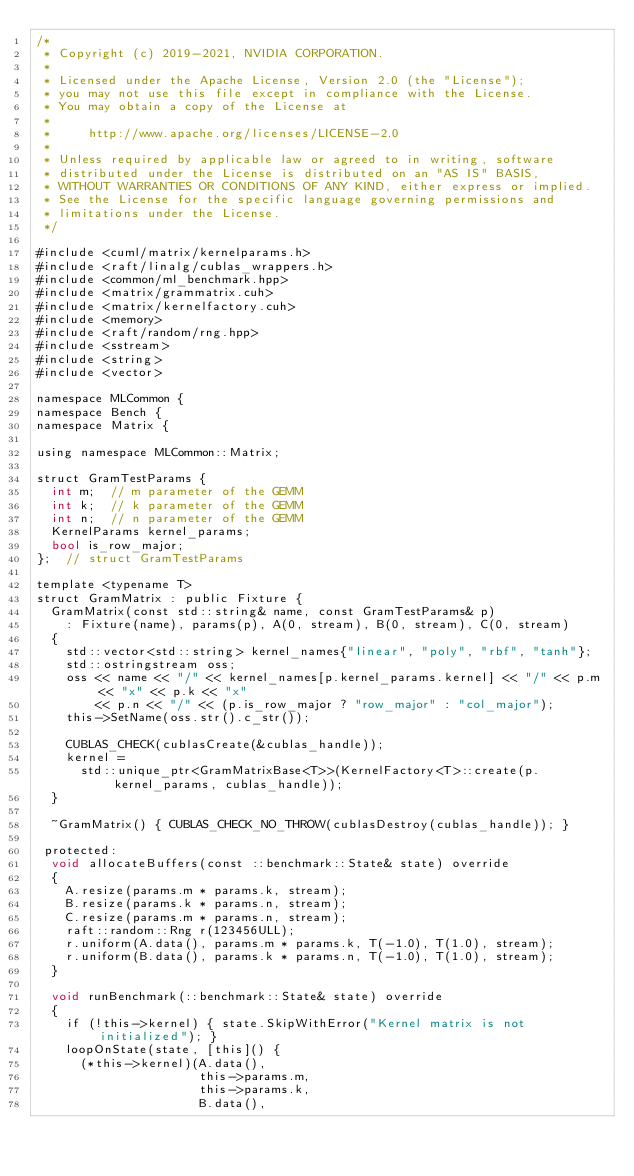Convert code to text. <code><loc_0><loc_0><loc_500><loc_500><_Cuda_>/*
 * Copyright (c) 2019-2021, NVIDIA CORPORATION.
 *
 * Licensed under the Apache License, Version 2.0 (the "License");
 * you may not use this file except in compliance with the License.
 * You may obtain a copy of the License at
 *
 *     http://www.apache.org/licenses/LICENSE-2.0
 *
 * Unless required by applicable law or agreed to in writing, software
 * distributed under the License is distributed on an "AS IS" BASIS,
 * WITHOUT WARRANTIES OR CONDITIONS OF ANY KIND, either express or implied.
 * See the License for the specific language governing permissions and
 * limitations under the License.
 */

#include <cuml/matrix/kernelparams.h>
#include <raft/linalg/cublas_wrappers.h>
#include <common/ml_benchmark.hpp>
#include <matrix/grammatrix.cuh>
#include <matrix/kernelfactory.cuh>
#include <memory>
#include <raft/random/rng.hpp>
#include <sstream>
#include <string>
#include <vector>

namespace MLCommon {
namespace Bench {
namespace Matrix {

using namespace MLCommon::Matrix;

struct GramTestParams {
  int m;  // m parameter of the GEMM
  int k;  // k parameter of the GEMM
  int n;  // n parameter of the GEMM
  KernelParams kernel_params;
  bool is_row_major;
};  // struct GramTestParams

template <typename T>
struct GramMatrix : public Fixture {
  GramMatrix(const std::string& name, const GramTestParams& p)
    : Fixture(name), params(p), A(0, stream), B(0, stream), C(0, stream)
  {
    std::vector<std::string> kernel_names{"linear", "poly", "rbf", "tanh"};
    std::ostringstream oss;
    oss << name << "/" << kernel_names[p.kernel_params.kernel] << "/" << p.m << "x" << p.k << "x"
        << p.n << "/" << (p.is_row_major ? "row_major" : "col_major");
    this->SetName(oss.str().c_str());

    CUBLAS_CHECK(cublasCreate(&cublas_handle));
    kernel =
      std::unique_ptr<GramMatrixBase<T>>(KernelFactory<T>::create(p.kernel_params, cublas_handle));
  }

  ~GramMatrix() { CUBLAS_CHECK_NO_THROW(cublasDestroy(cublas_handle)); }

 protected:
  void allocateBuffers(const ::benchmark::State& state) override
  {
    A.resize(params.m * params.k, stream);
    B.resize(params.k * params.n, stream);
    C.resize(params.m * params.n, stream);
    raft::random::Rng r(123456ULL);
    r.uniform(A.data(), params.m * params.k, T(-1.0), T(1.0), stream);
    r.uniform(B.data(), params.k * params.n, T(-1.0), T(1.0), stream);
  }

  void runBenchmark(::benchmark::State& state) override
  {
    if (!this->kernel) { state.SkipWithError("Kernel matrix is not initialized"); }
    loopOnState(state, [this]() {
      (*this->kernel)(A.data(),
                      this->params.m,
                      this->params.k,
                      B.data(),</code> 